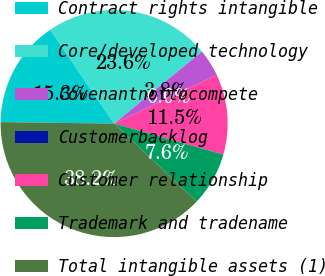Convert chart. <chart><loc_0><loc_0><loc_500><loc_500><pie_chart><fcel>Contract rights intangible<fcel>Core/developed technology<fcel>Covenantnottocompete<fcel>Customerbacklog<fcel>Customer relationship<fcel>Trademark and tradename<fcel>Total intangible assets (1)<nl><fcel>15.28%<fcel>23.58%<fcel>3.84%<fcel>0.03%<fcel>11.47%<fcel>7.65%<fcel>38.15%<nl></chart> 